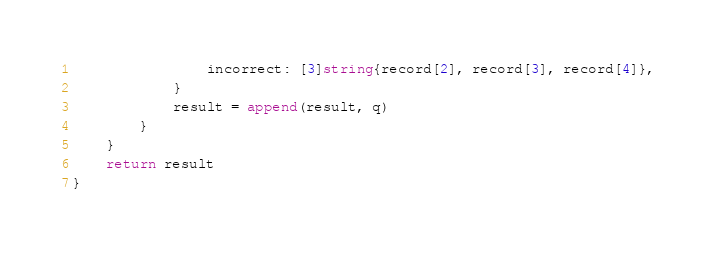Convert code to text. <code><loc_0><loc_0><loc_500><loc_500><_Go_>				incorrect: [3]string{record[2], record[3], record[4]},
			}
			result = append(result, q)
		}
	}
	return result
}
</code> 